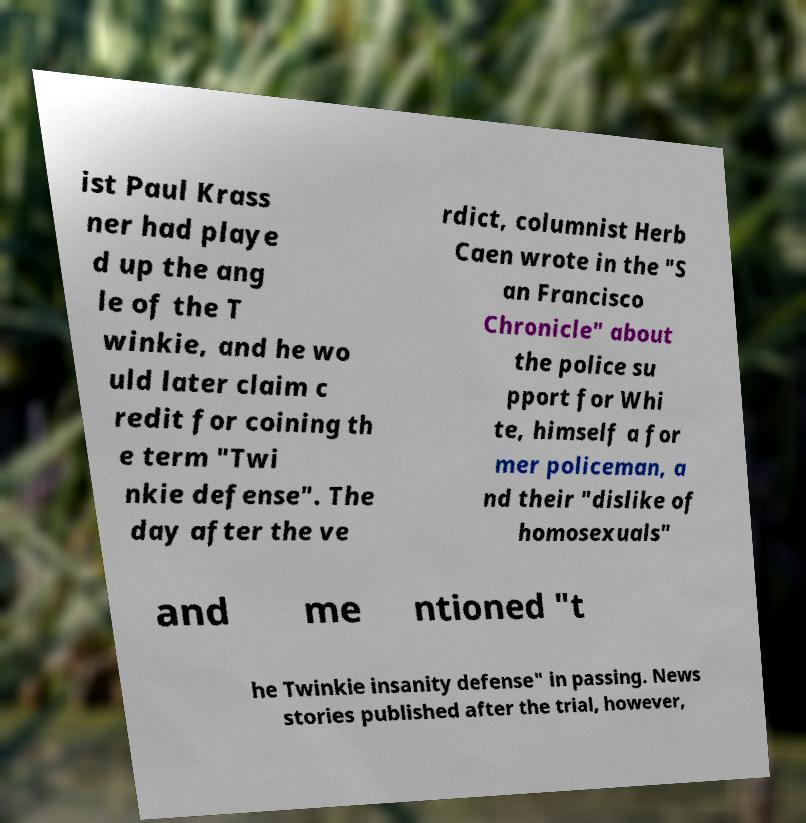There's text embedded in this image that I need extracted. Can you transcribe it verbatim? ist Paul Krass ner had playe d up the ang le of the T winkie, and he wo uld later claim c redit for coining th e term "Twi nkie defense". The day after the ve rdict, columnist Herb Caen wrote in the "S an Francisco Chronicle" about the police su pport for Whi te, himself a for mer policeman, a nd their "dislike of homosexuals" and me ntioned "t he Twinkie insanity defense" in passing. News stories published after the trial, however, 